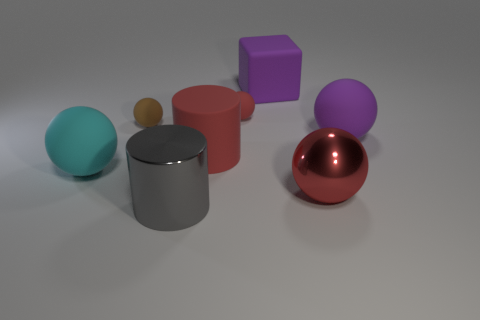What size is the purple matte thing behind the tiny matte ball that is to the left of the gray metal cylinder?
Your response must be concise. Large. How many things are either metallic blocks or tiny spheres?
Your answer should be very brief. 2. Is there a small matte sphere of the same color as the matte cylinder?
Give a very brief answer. Yes. Are there fewer gray shiny things than purple things?
Make the answer very short. Yes. How many objects are big red things or red things on the right side of the big purple block?
Your answer should be very brief. 2. Are there any other cylinders that have the same material as the red cylinder?
Provide a succinct answer. No. There is a brown object that is the same size as the red rubber ball; what is it made of?
Your answer should be compact. Rubber. What is the object that is on the left side of the brown thing in front of the large rubber block made of?
Provide a short and direct response. Rubber. There is a purple thing behind the small brown matte sphere; is its shape the same as the big red rubber thing?
Your answer should be compact. No. What is the color of the big ball that is the same material as the big gray cylinder?
Ensure brevity in your answer.  Red. 